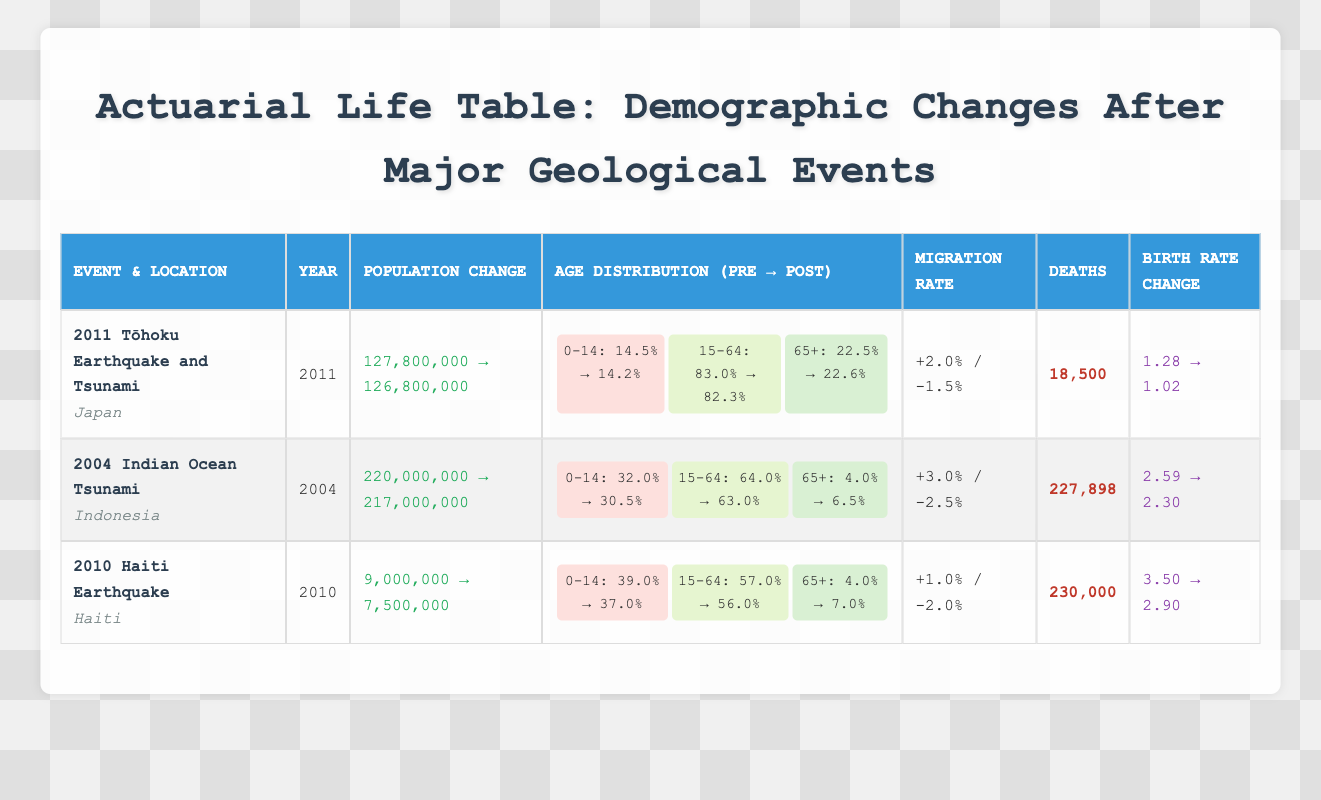What was the population change in Japan after the 2011 Tōhoku Earthquake and Tsunami? The pre-event population of Japan in 2011 was 127,800,000, and the post-event population was 126,800,000. The change in population can be determined by subtracting the post-event population from the pre-event population: 127,800,000 - 126,800,000 = 1,000,000.
Answer: 1,000,000 Did the percentage of the population aged 0-14 in Indonesia increase or decrease after the 2004 Indian Ocean Tsunami? The percentage of the population aged 0-14 in Indonesia before the tsunami was 32.0%, and it decreased to 30.5% after the event. Thus, it is true that the percentage decreased after the tsunami.
Answer: Decreased What was the change in birth rate from pre-event to post-event in Haiti following the 2010 earthquake? The birth rate in Haiti before the event was 3.50, and it dropped to 2.90 after the earthquake. The change can be calculated by subtracting the post-event rate from the pre-event rate: 3.50 - 2.90 = 0.60. Thus, the birth rate decreased by 0.60.
Answer: Decreased by 0.60 How many more deaths occurred as a result of the 2010 Haiti Earthquake compared to the 2011 Tōhoku Earthquake? The deaths from the Haiti earthquake were 230,000, while the Tōhoku earthquake caused 18,500 deaths. To find the difference, subtract the number of deaths from the Tōhoku earthquake from the number of deaths from the Haiti earthquake: 230,000 - 18,500 = 211,500.
Answer: 211,500 Which event had the highest percentage of the population aged 65+ post-event? The post-event age distributions show that Indonesia had 6.5% of its population aged 65+ after the Indian Ocean tsunami, Japan had 22.6% after the Tōhoku event, and Haiti had 7.0% after the earthquake. Comparing these percentages, Japan's percentage of 22.6% is the highest.
Answer: Japan (22.6%) What was the net change in the migration rate for Indonesia following the 2004 Indian Ocean Tsunami? The migration rate for Indonesia indicates an increase of 3.0% and a decrease of 2.5%. The net change is calculated by subtracting the decrease from the increase: 3.0% - 2.5% = 0.5%. Therefore, the net change in the migration rate is an increase of 0.5%.
Answer: 0.5% increase Was the death toll in the 2004 Indian Ocean Tsunami higher than in the 2011 Tōhoku Earthquake? The death toll for the Indian Ocean Tsunami was 227,898, compared to 18,500 for the Tōhoku Earthquake. Since 227,898 is greater than 18,500, it is true that the death toll for the tsunami was indeed higher.
Answer: Yes What is the overall percentage decrease in the population of Haiti after the 2010 earthquake? The population before the earthquake was 9,000,000, and it decreased to 7,500,000. The decrease is calculated as: (9,000,000 - 7,500,000) / 9,000,000 * 100 = 16.67%. Thus, the overall percentage decrease in population is approximately 16.67%.
Answer: 16.67% 